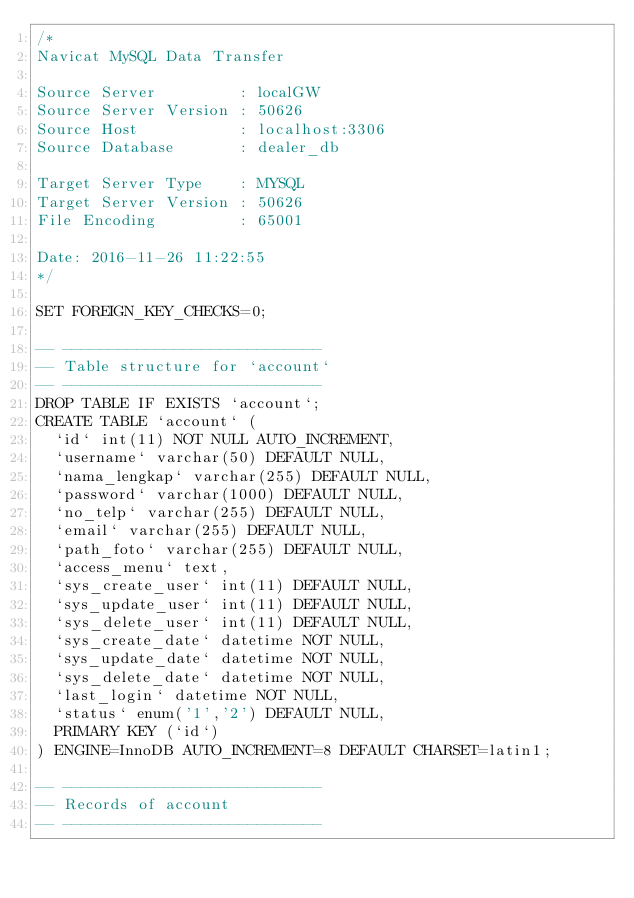<code> <loc_0><loc_0><loc_500><loc_500><_SQL_>/*
Navicat MySQL Data Transfer

Source Server         : localGW
Source Server Version : 50626
Source Host           : localhost:3306
Source Database       : dealer_db

Target Server Type    : MYSQL
Target Server Version : 50626
File Encoding         : 65001

Date: 2016-11-26 11:22:55
*/

SET FOREIGN_KEY_CHECKS=0;

-- ----------------------------
-- Table structure for `account`
-- ----------------------------
DROP TABLE IF EXISTS `account`;
CREATE TABLE `account` (
  `id` int(11) NOT NULL AUTO_INCREMENT,
  `username` varchar(50) DEFAULT NULL,
  `nama_lengkap` varchar(255) DEFAULT NULL,
  `password` varchar(1000) DEFAULT NULL,
  `no_telp` varchar(255) DEFAULT NULL,
  `email` varchar(255) DEFAULT NULL,
  `path_foto` varchar(255) DEFAULT NULL,
  `access_menu` text,
  `sys_create_user` int(11) DEFAULT NULL,
  `sys_update_user` int(11) DEFAULT NULL,
  `sys_delete_user` int(11) DEFAULT NULL,
  `sys_create_date` datetime NOT NULL,
  `sys_update_date` datetime NOT NULL,
  `sys_delete_date` datetime NOT NULL,
  `last_login` datetime NOT NULL,
  `status` enum('1','2') DEFAULT NULL,
  PRIMARY KEY (`id`)
) ENGINE=InnoDB AUTO_INCREMENT=8 DEFAULT CHARSET=latin1;

-- ----------------------------
-- Records of account
-- ----------------------------</code> 